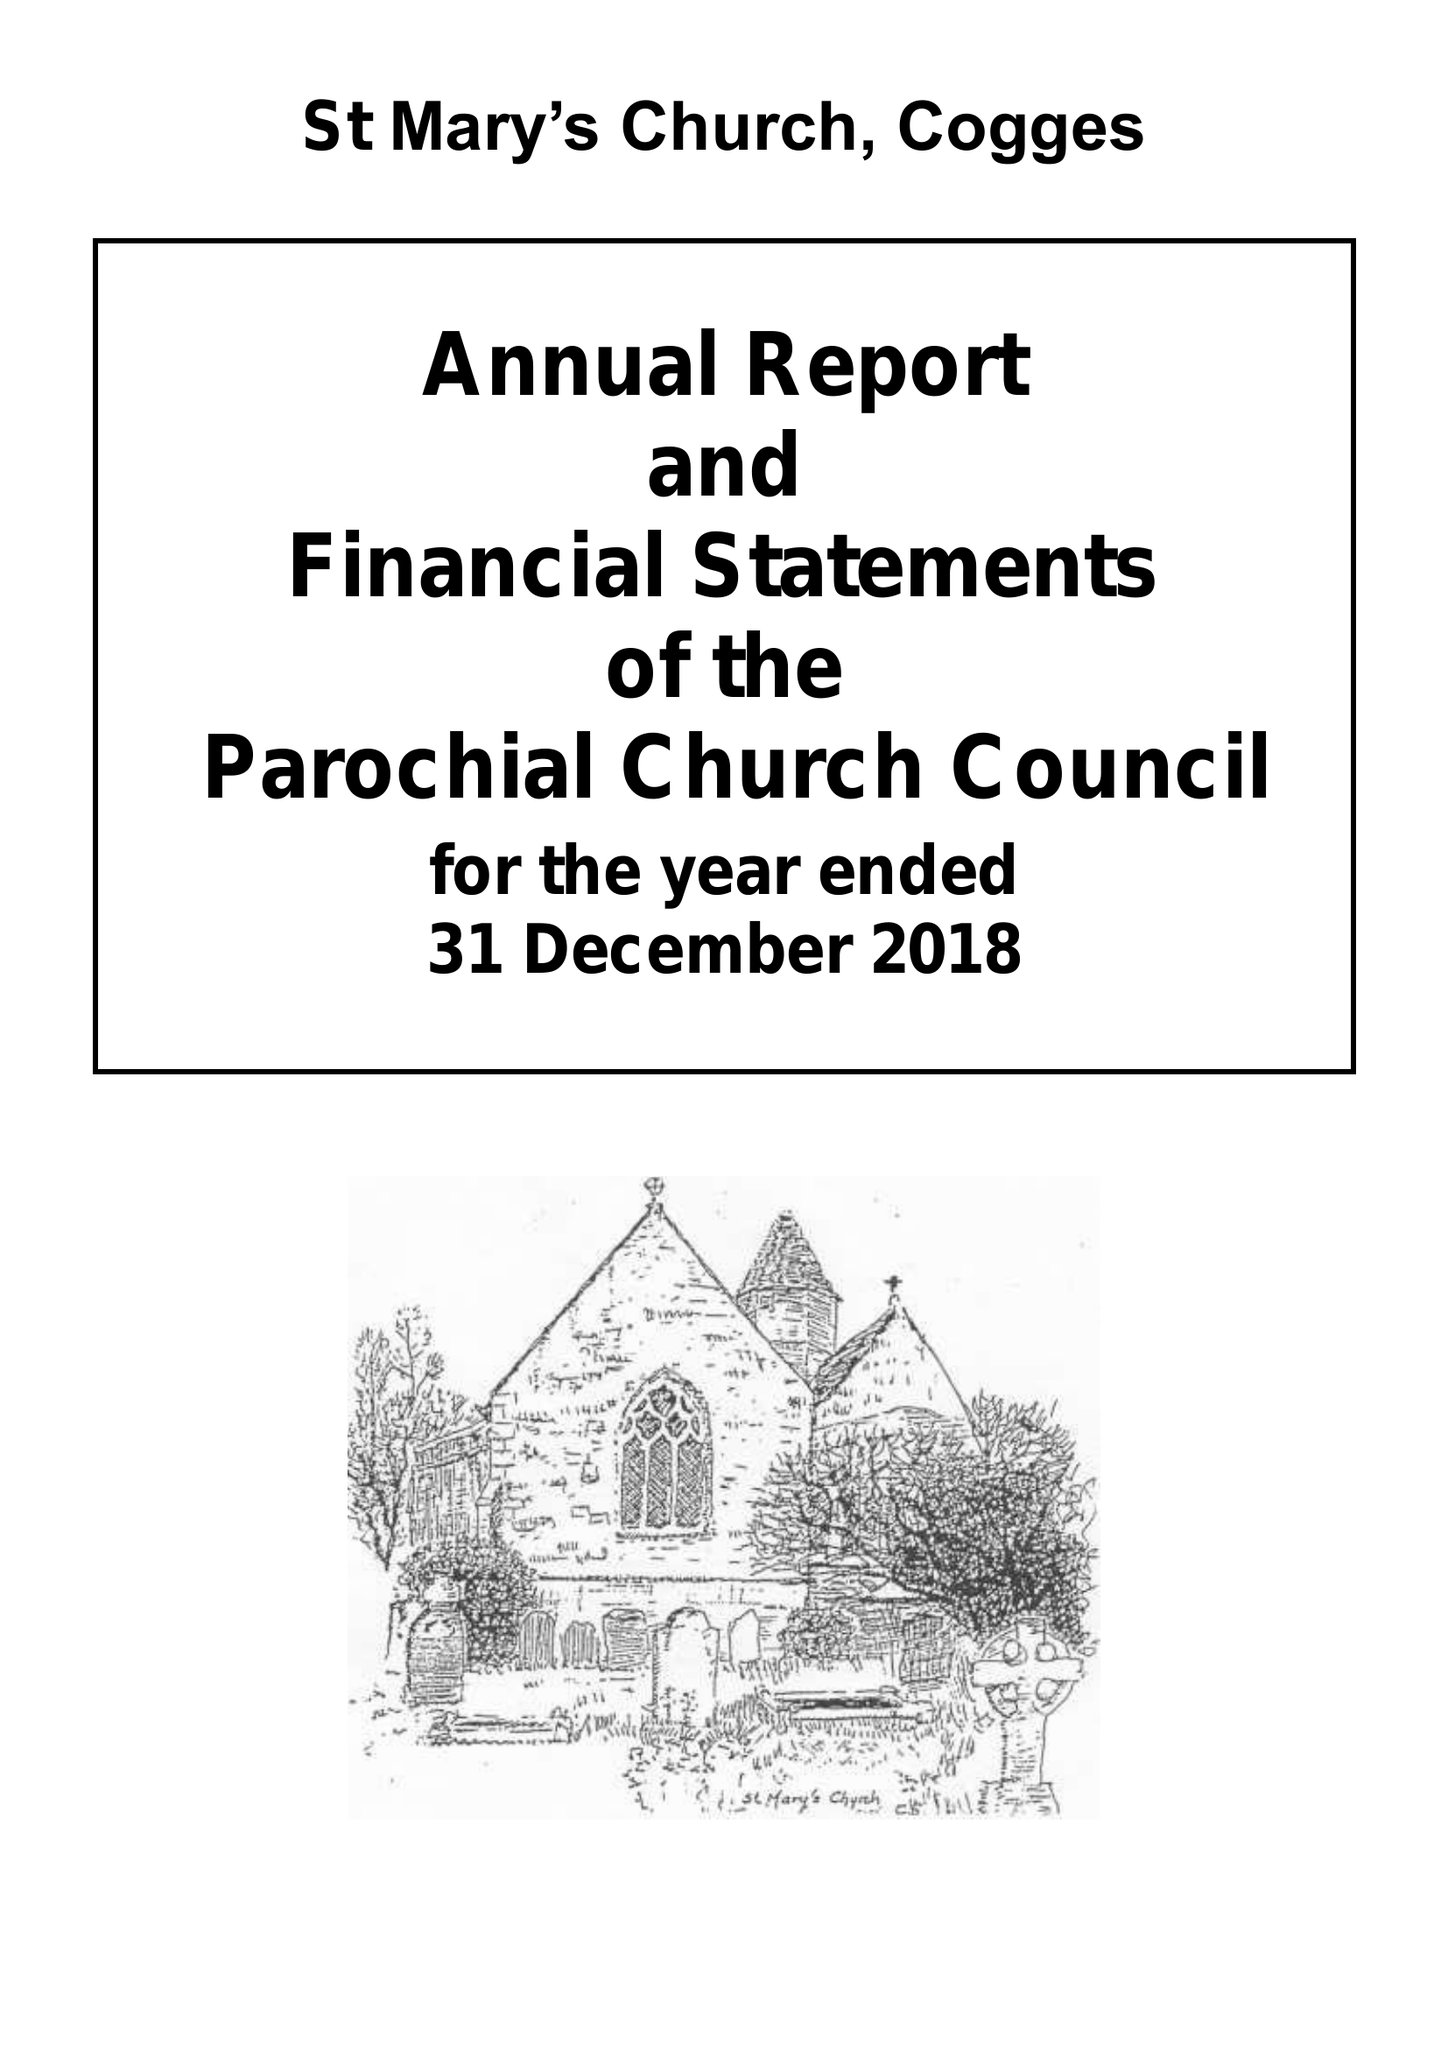What is the value for the address__street_line?
Answer the question using a single word or phrase. CHURCH LANE 